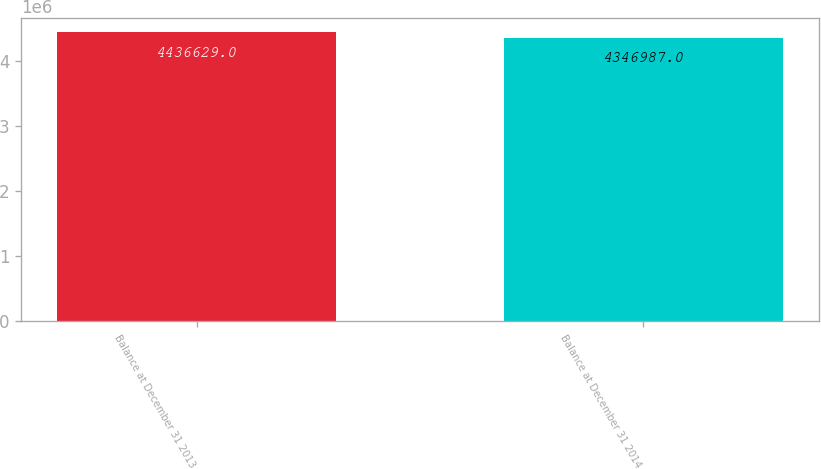<chart> <loc_0><loc_0><loc_500><loc_500><bar_chart><fcel>Balance at December 31 2013<fcel>Balance at December 31 2014<nl><fcel>4.43663e+06<fcel>4.34699e+06<nl></chart> 